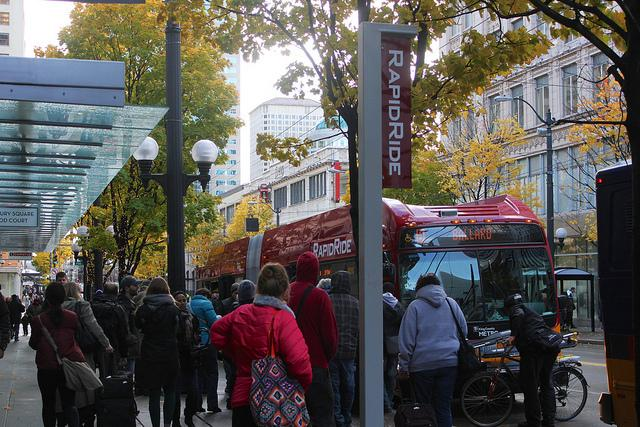What area is shown here? Please explain your reasoning. bus stop. People stand at a covered area near the curb of a busy street as a bus approaches. 